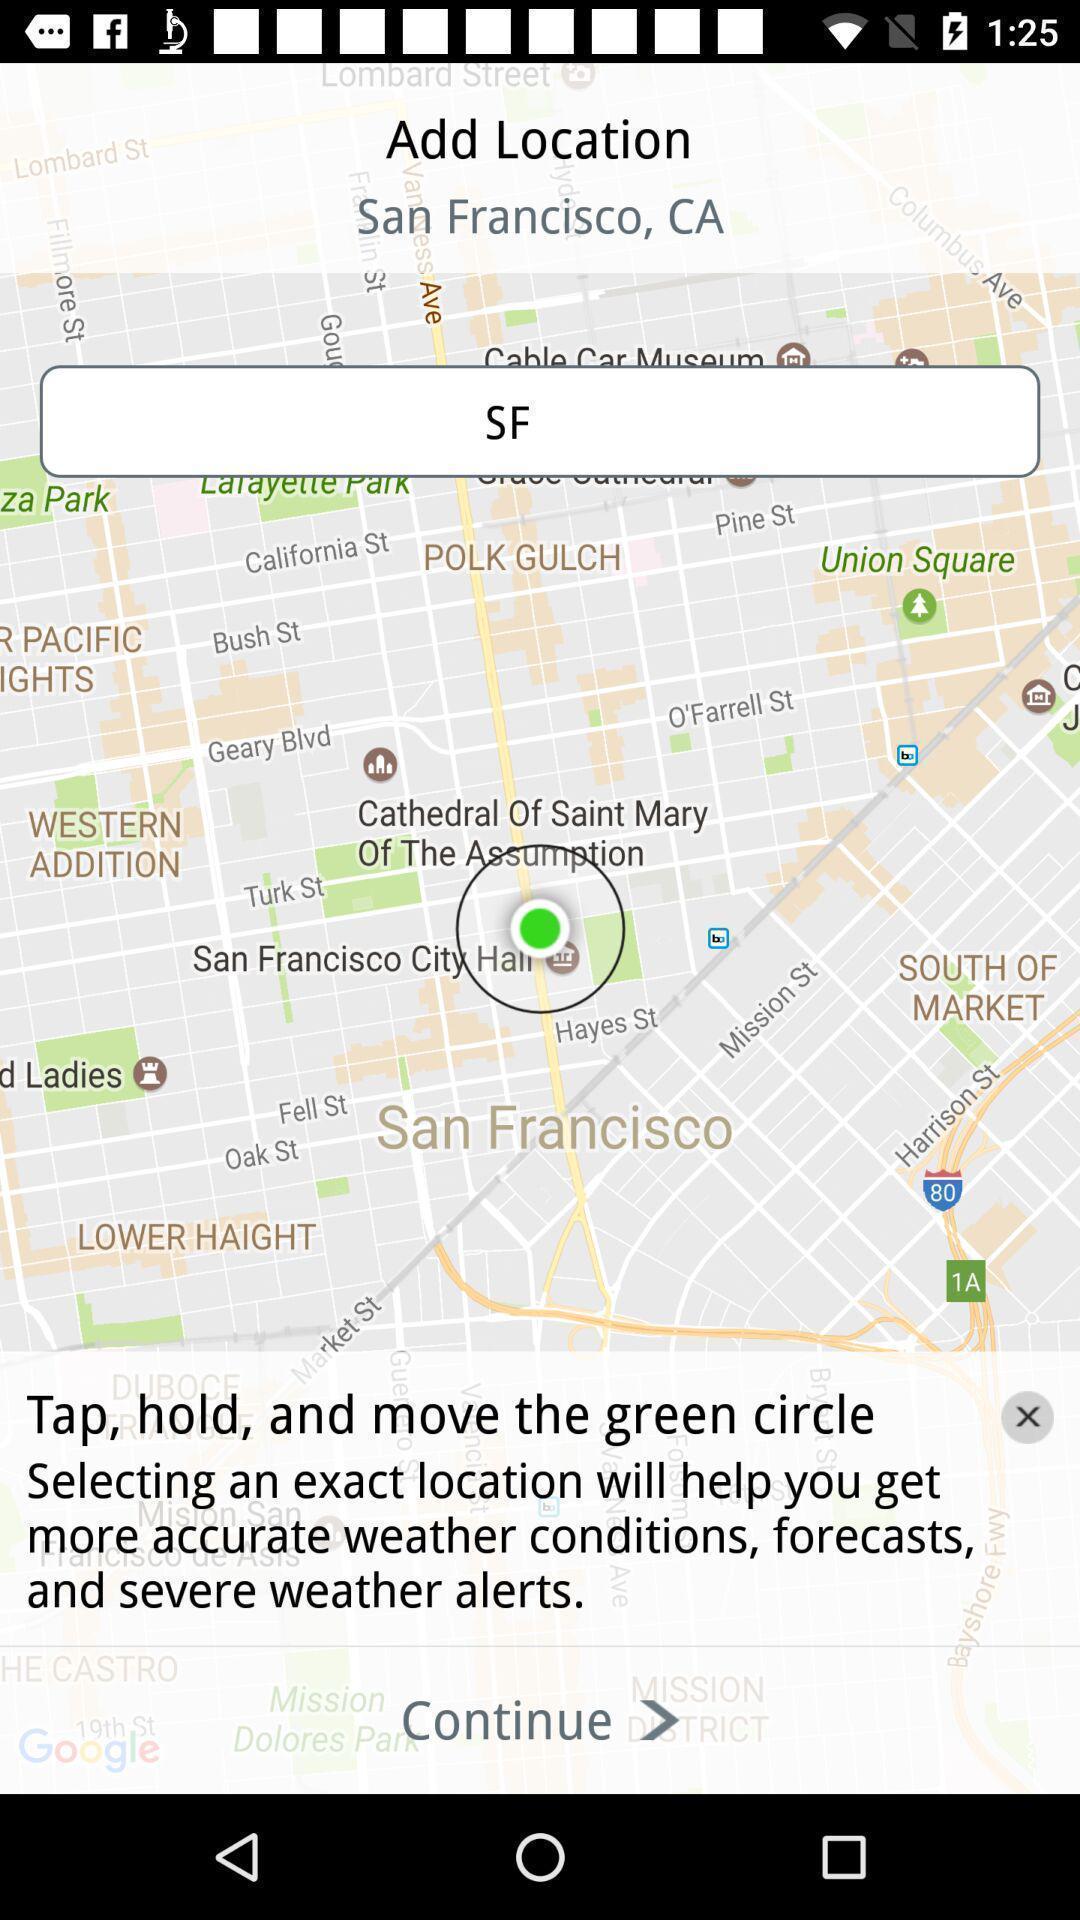Tell me what you see in this picture. Screen asking to add a location. 